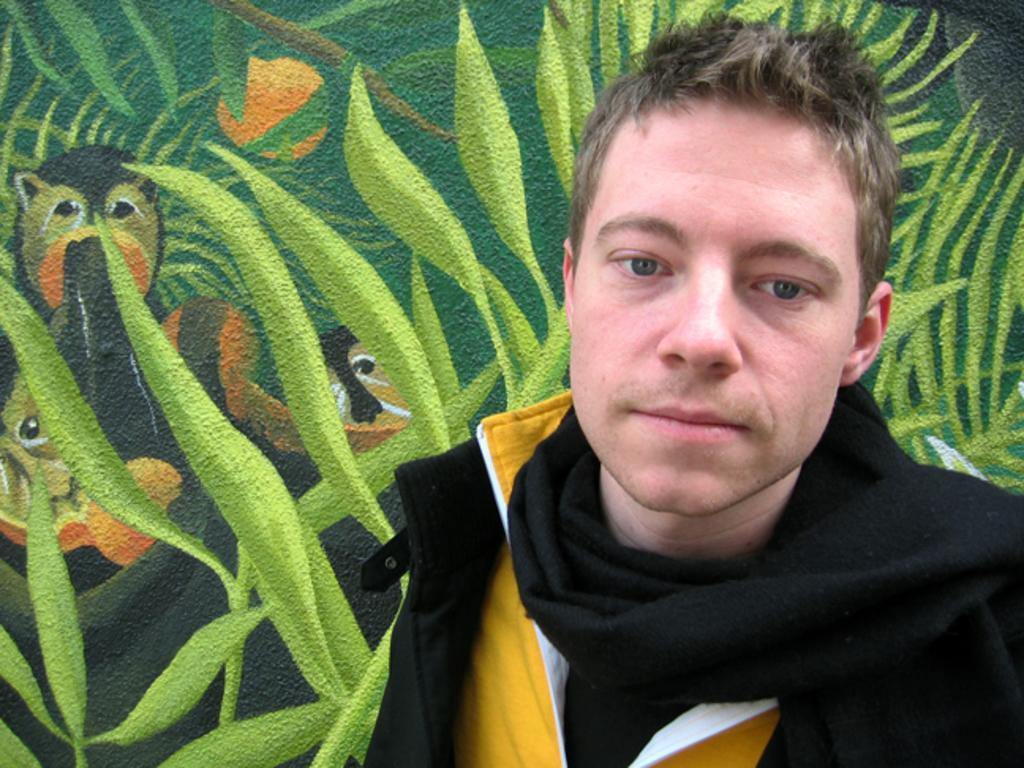In one or two sentences, can you explain what this image depicts? In this picture I can see a man standing, He wore a black color scarf and a black color coat and I can see painting of leaves and animals on the wall. 